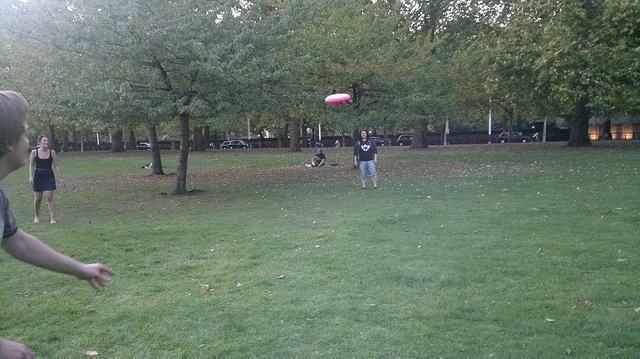How many people are playing?
Give a very brief answer. 3. How many elephant are facing the right side of the image?
Give a very brief answer. 0. 